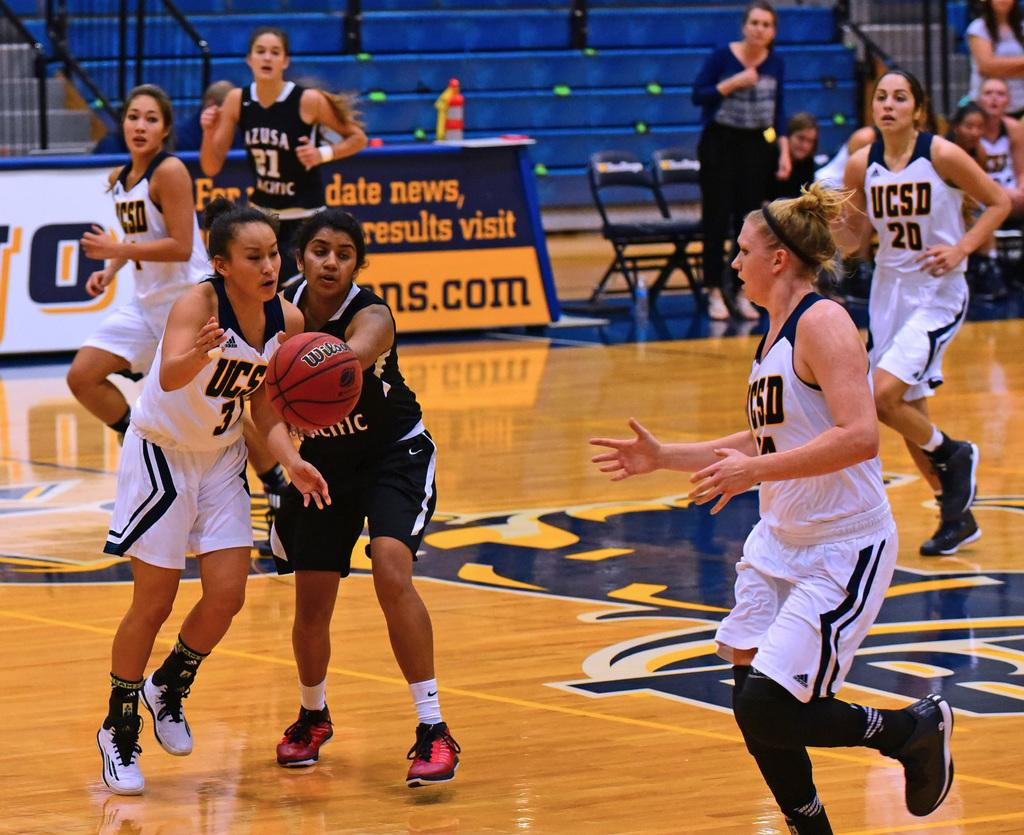What activity are the women engaged in within the image? The women are playing with a basketball in the image. Where are the women located in the image? The women are on the ground. What can be seen in the background of the image? There are stairs, chairs, and persons in the background of the image. How many bikes are parked near the women in the image? There are no bikes present in the image. What type of hook is used to hang the basketball in the image? There is no hook used to hang the basketball in the image; it is being played with by the women. 